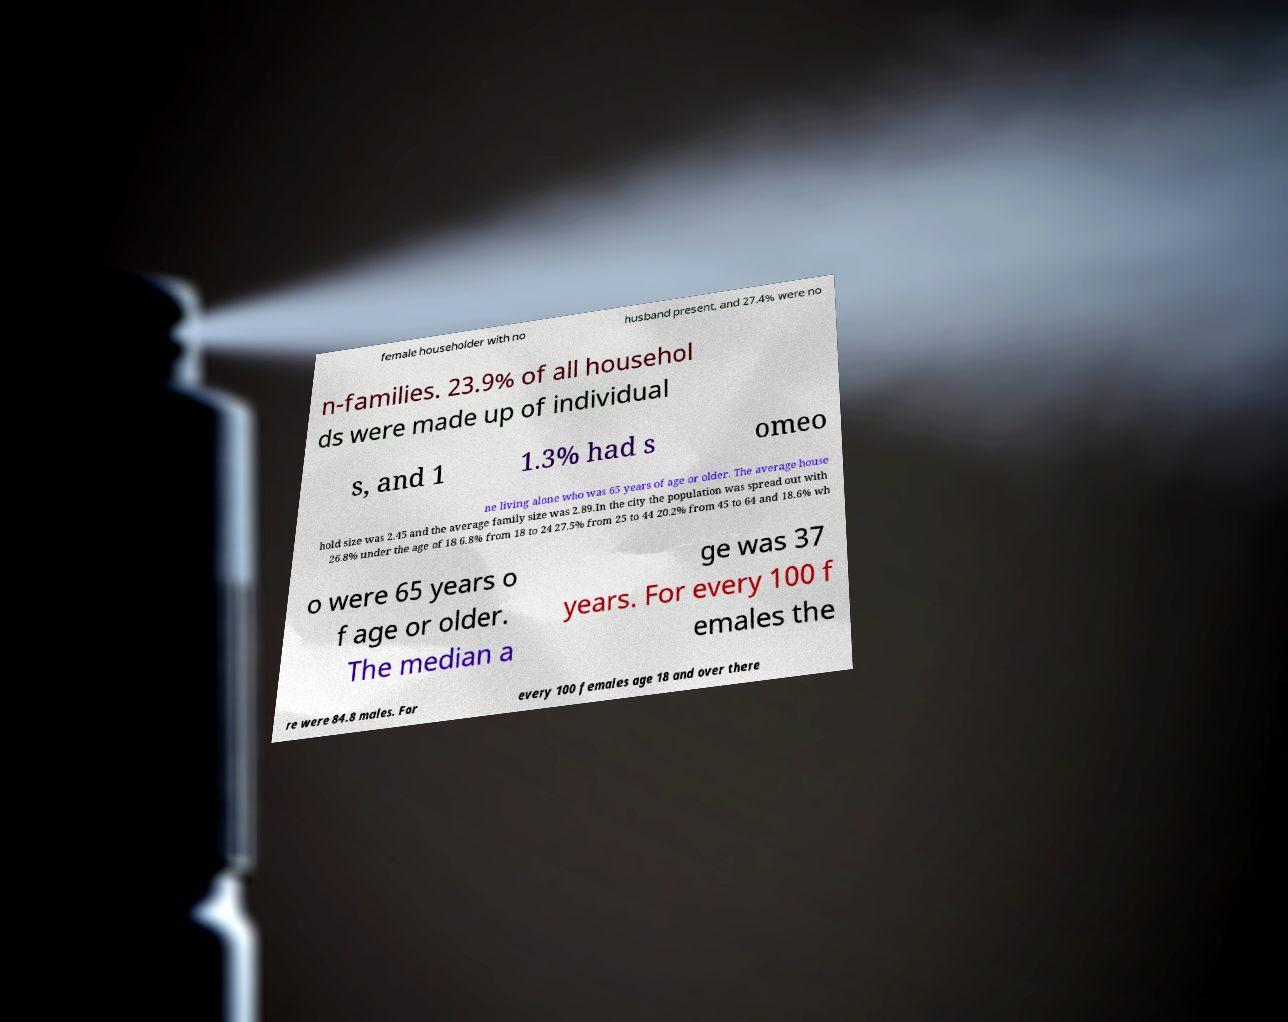I need the written content from this picture converted into text. Can you do that? female householder with no husband present, and 27.4% were no n-families. 23.9% of all househol ds were made up of individual s, and 1 1.3% had s omeo ne living alone who was 65 years of age or older. The average house hold size was 2.45 and the average family size was 2.89.In the city the population was spread out with 26.8% under the age of 18 6.8% from 18 to 24 27.5% from 25 to 44 20.2% from 45 to 64 and 18.6% wh o were 65 years o f age or older. The median a ge was 37 years. For every 100 f emales the re were 84.8 males. For every 100 females age 18 and over there 